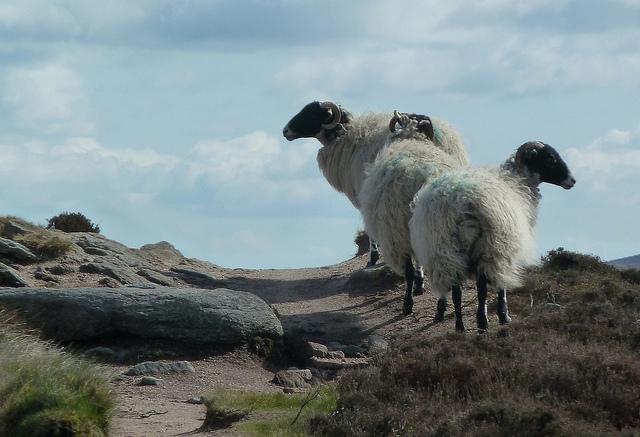How many animals are in the photo?
Give a very brief answer. 3. How many sheep are in the picture?
Give a very brief answer. 3. 